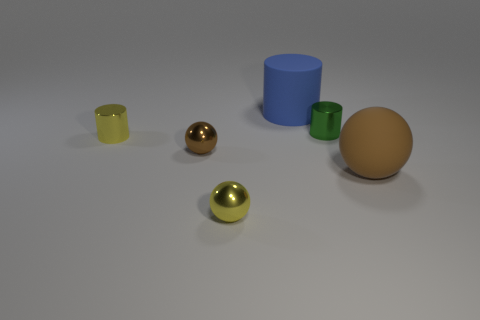Add 1 large red metal things. How many objects exist? 7 Subtract all brown balls. How many balls are left? 1 Subtract 3 balls. How many balls are left? 0 Subtract all brown balls. Subtract all blue cylinders. How many balls are left? 1 Subtract all purple balls. How many purple cylinders are left? 0 Subtract all big purple matte cylinders. Subtract all small metallic balls. How many objects are left? 4 Add 3 cylinders. How many cylinders are left? 6 Add 6 big blue cylinders. How many big blue cylinders exist? 7 Subtract all brown balls. How many balls are left? 1 Subtract 0 gray blocks. How many objects are left? 6 